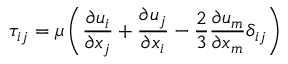<formula> <loc_0><loc_0><loc_500><loc_500>\tau _ { i j } = \mu \left ( \frac { \partial { u _ { i } } } { \partial { x _ { j } } } + \frac { \partial { u _ { j } } } { \partial { x _ { i } } } - \frac { 2 } { 3 } \frac { \partial { u _ { m } } } { \partial { x _ { m } } } \delta _ { i j } \right )</formula> 